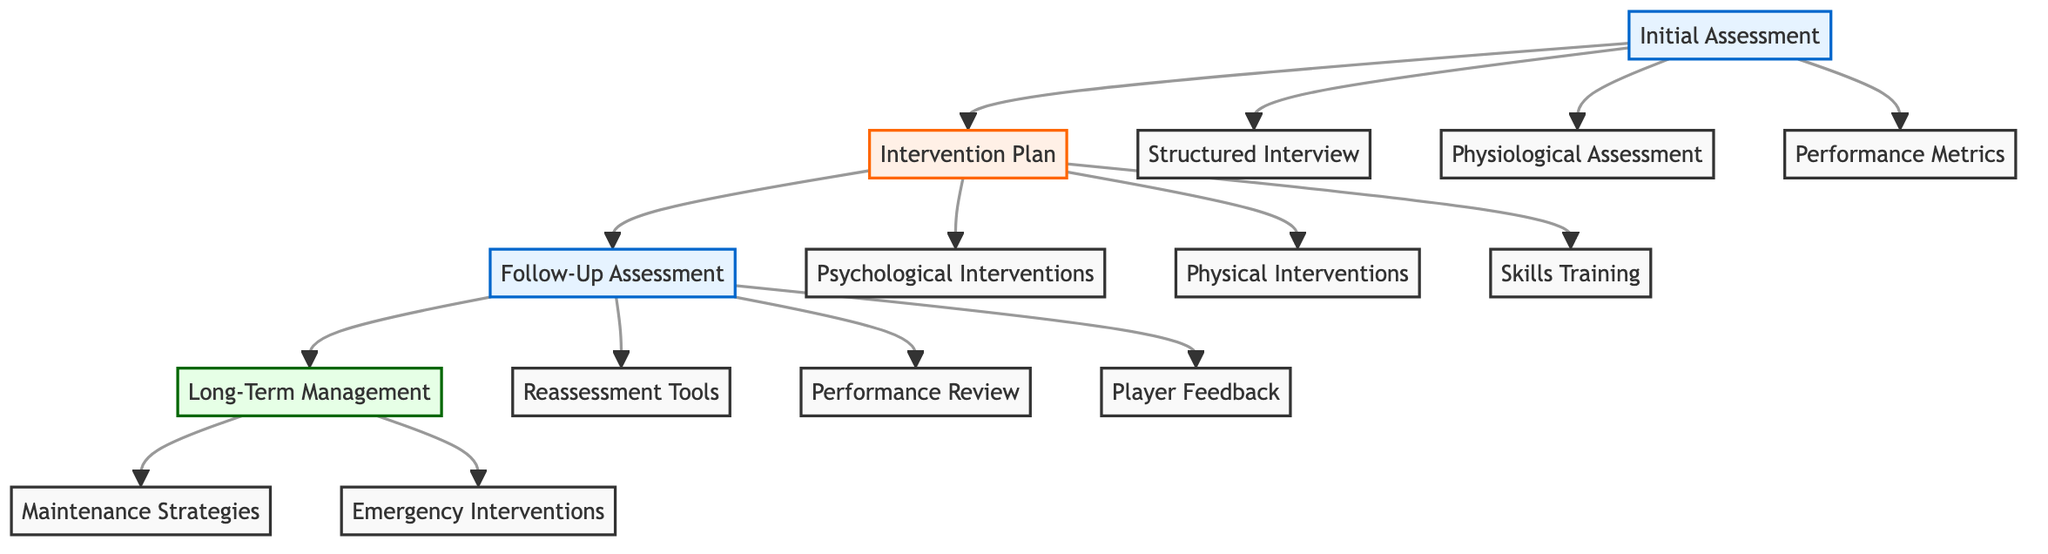What are the components of Initial Assessment? The Initial Assessment node connects to three components: Structured Interview, Physiological Assessment, and Performance Metrics. Each of these is a distinct aspect evaluated at the beginning of the clinical pathway.
Answer: Structured Interview, Physiological Assessment, Performance Metrics How many psychological interventions are listed in the Intervention Plan? The Intervention Plan node branches out to three specific categories, one of which is Psychological Interventions. Under this category, three distinct interventions are listed. Thus, counting them gives the total.
Answer: 3 What is the purpose of the Follow-Up Assessment? The Follow-Up Assessment node leads to three components: Reassessment Tools, Performance Review, and Player Feedback. Each aspect serves to evaluate the effectiveness of the previous interventions and provides needed information on the player's current status.
Answer: Evaluate effectiveness What does the Long-Term Management section include? The Long-Term Management node dives into two main components: Maintenance Strategies and Emergency Interventions. Each of these is designed to assist in the sustained well-being and performance of the pitchers over time.
Answer: Maintenance Strategies, Emergency Interventions Which intervention is categorized under Physical Interventions? The Intervention Plan includes several types of interventions. Under Physical Interventions specifically, breathing exercises are listed as one of the strategies implemented for the pitchers.
Answer: Breathing Exercises How is performance monitored after the intervention? The Follow-Up Assessment checks three main components: Reassessment Tools which include the Beck Anxiety Inventory, Performance Review which looks at metrics (like Pitch Speed), and Player Feedback where players report their stress and confidence. This systematic review helps assess progress.
Answer: Reassessment Tools, Performance Review, Player Feedback What is emphasized in the Maintenance Strategies? Maintenance Strategies in the Long-Term Management include ongoing practices that ensure that pitchers can maintain their mental performance. Among these practices, ongoing mindfulness practice is specifically mentioned.
Answer: Ongoing Mindfulness Practice What does Player Feedback assess? In the Follow-Up Assessment, Player Feedback primarily gathers self-reported data from the player regarding two aspects: their stress and confidence levels. This qualitative feedback is crucial to understanding a pitcher's mental state post-intervention.
Answer: Self-Reported Stress and Confidence Levels 